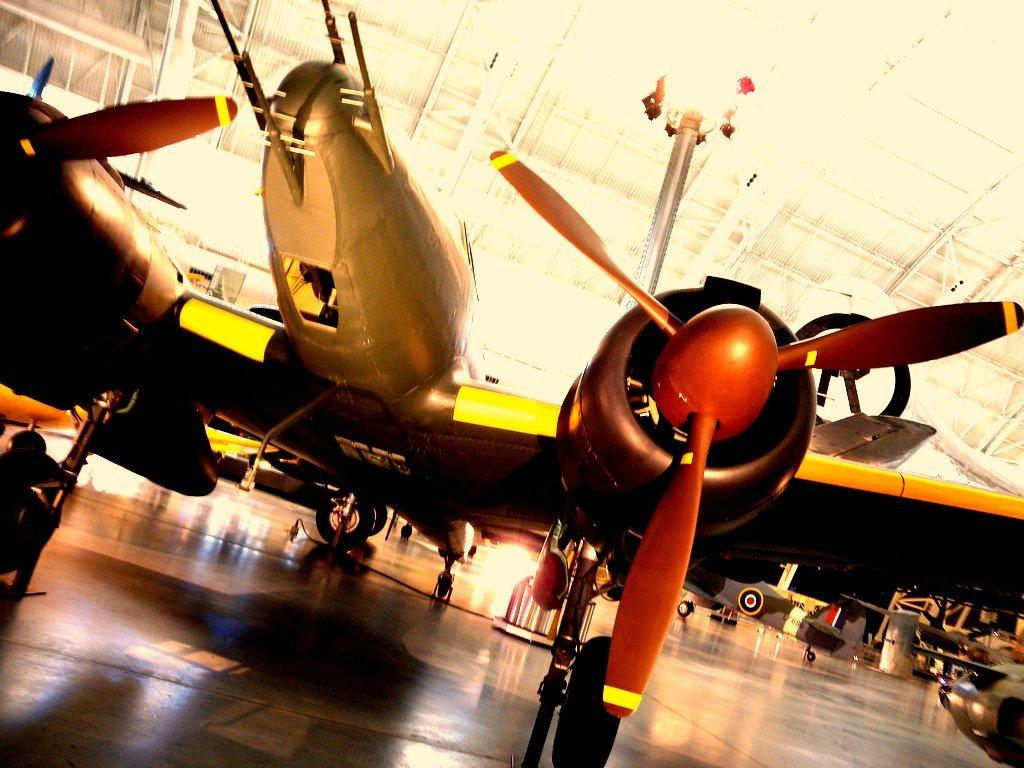What is the main subject of the image? The main subject of the image is airplanes. Are there any other objects present in the image besides the airplanes? Yes, there are other objects in the image. Can you describe the lights visible in the image? There are lights visible in the image. How does the needle help the airplanes in the image? There is no needle present in the image, so it cannot help the airplanes. 